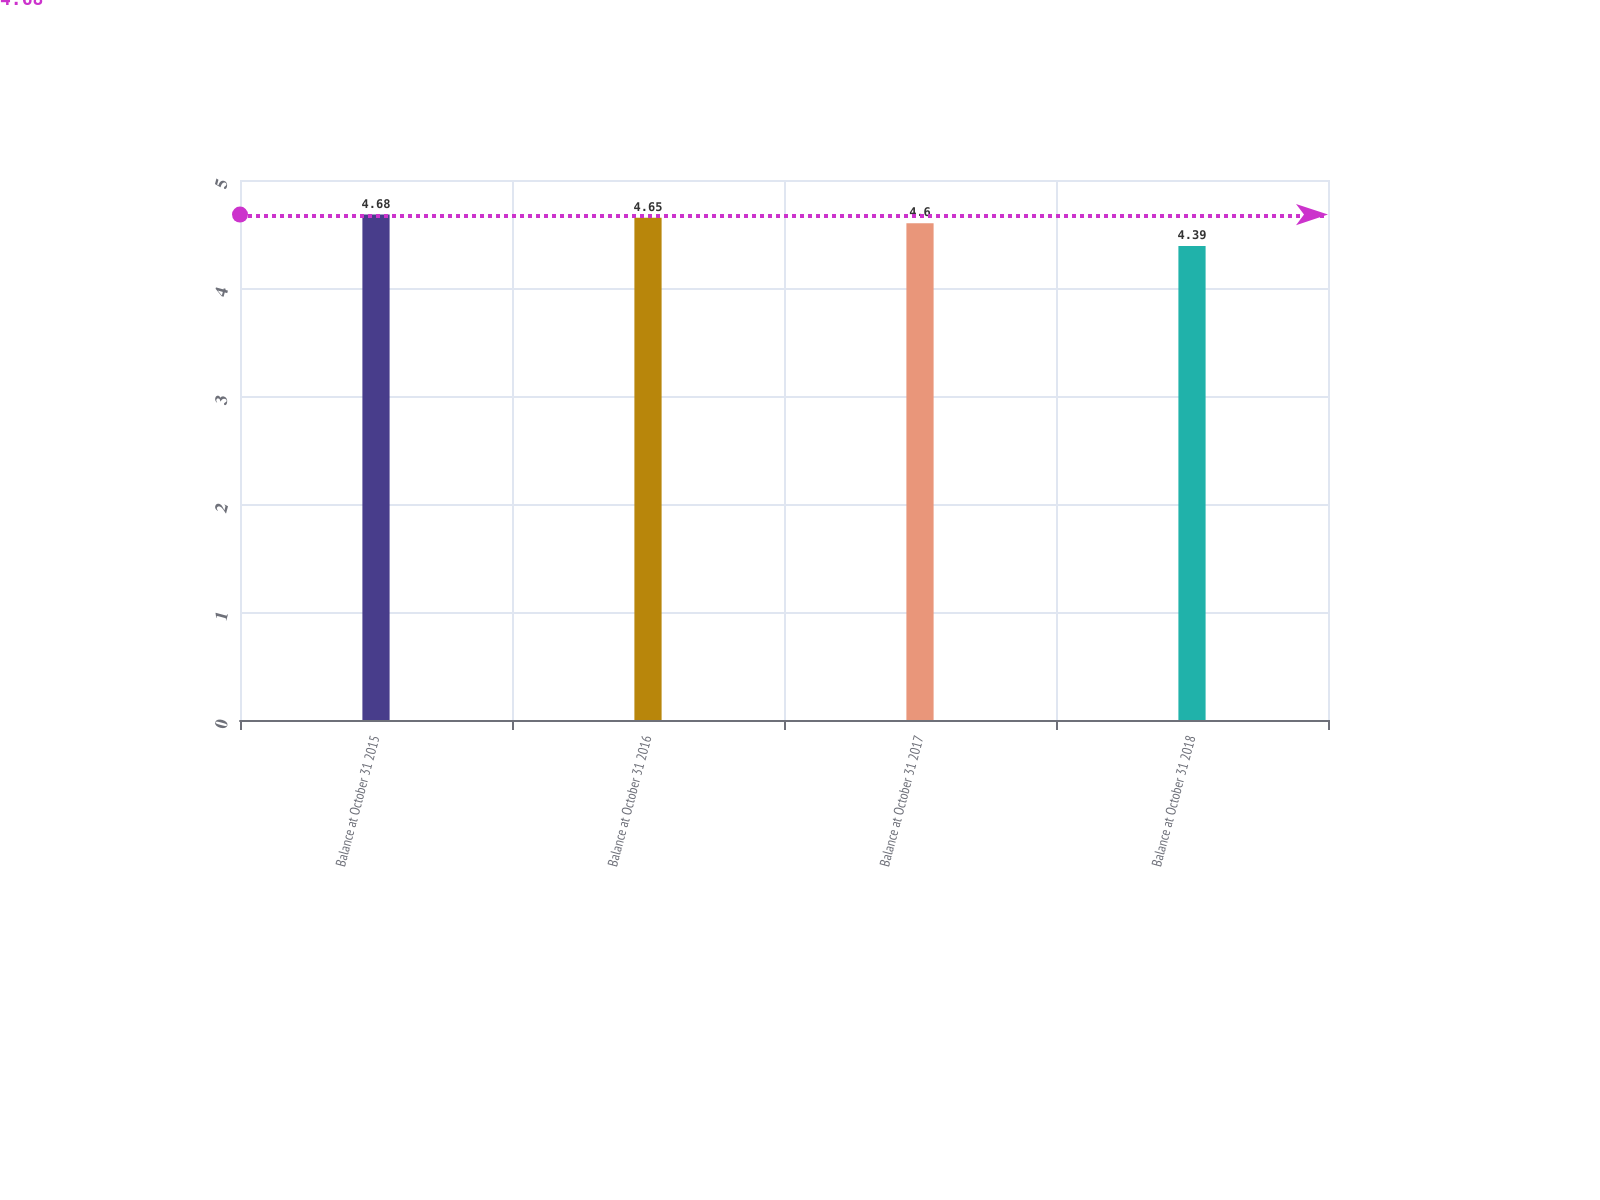<chart> <loc_0><loc_0><loc_500><loc_500><bar_chart><fcel>Balance at October 31 2015<fcel>Balance at October 31 2016<fcel>Balance at October 31 2017<fcel>Balance at October 31 2018<nl><fcel>4.68<fcel>4.65<fcel>4.6<fcel>4.39<nl></chart> 